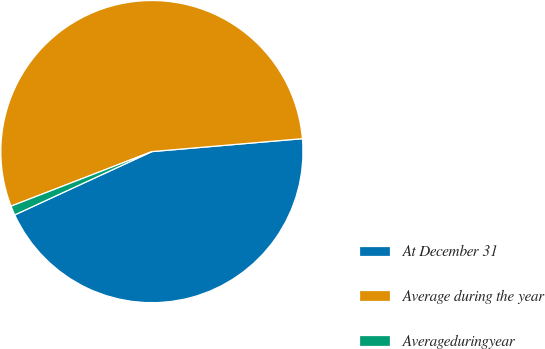<chart> <loc_0><loc_0><loc_500><loc_500><pie_chart><fcel>At December 31<fcel>Average during the year<fcel>Averageduringyear<nl><fcel>44.48%<fcel>54.52%<fcel>1.0%<nl></chart> 